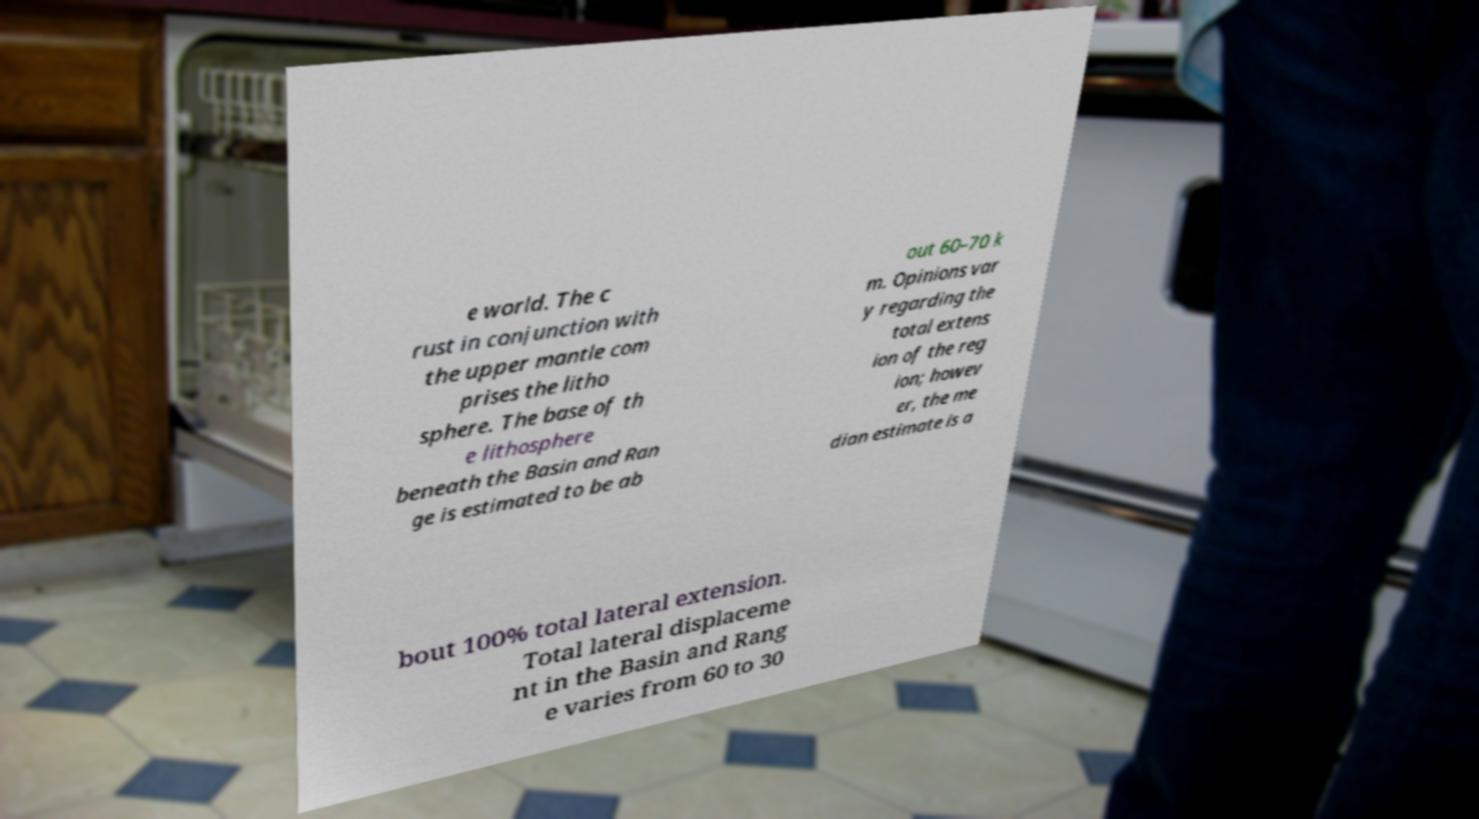Can you accurately transcribe the text from the provided image for me? e world. The c rust in conjunction with the upper mantle com prises the litho sphere. The base of th e lithosphere beneath the Basin and Ran ge is estimated to be ab out 60–70 k m. Opinions var y regarding the total extens ion of the reg ion; howev er, the me dian estimate is a bout 100% total lateral extension. Total lateral displaceme nt in the Basin and Rang e varies from 60 to 30 